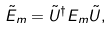<formula> <loc_0><loc_0><loc_500><loc_500>\tilde { E } _ { m } = \tilde { U } ^ { \dagger } E _ { m } \tilde { U } ,</formula> 